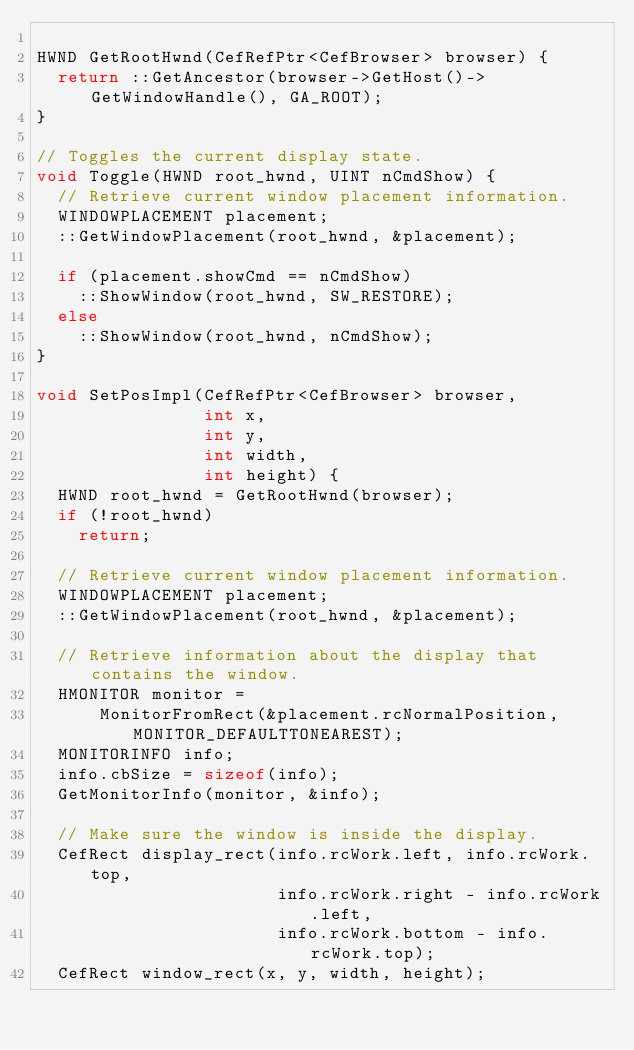Convert code to text. <code><loc_0><loc_0><loc_500><loc_500><_C++_>
HWND GetRootHwnd(CefRefPtr<CefBrowser> browser) {
  return ::GetAncestor(browser->GetHost()->GetWindowHandle(), GA_ROOT);
}

// Toggles the current display state.
void Toggle(HWND root_hwnd, UINT nCmdShow) {
  // Retrieve current window placement information.
  WINDOWPLACEMENT placement;
  ::GetWindowPlacement(root_hwnd, &placement);

  if (placement.showCmd == nCmdShow)
    ::ShowWindow(root_hwnd, SW_RESTORE);
  else
    ::ShowWindow(root_hwnd, nCmdShow);
}

void SetPosImpl(CefRefPtr<CefBrowser> browser,
                int x,
                int y,
                int width,
                int height) {
  HWND root_hwnd = GetRootHwnd(browser);
  if (!root_hwnd)
    return;

  // Retrieve current window placement information.
  WINDOWPLACEMENT placement;
  ::GetWindowPlacement(root_hwnd, &placement);

  // Retrieve information about the display that contains the window.
  HMONITOR monitor =
      MonitorFromRect(&placement.rcNormalPosition, MONITOR_DEFAULTTONEAREST);
  MONITORINFO info;
  info.cbSize = sizeof(info);
  GetMonitorInfo(monitor, &info);

  // Make sure the window is inside the display.
  CefRect display_rect(info.rcWork.left, info.rcWork.top,
                       info.rcWork.right - info.rcWork.left,
                       info.rcWork.bottom - info.rcWork.top);
  CefRect window_rect(x, y, width, height);</code> 